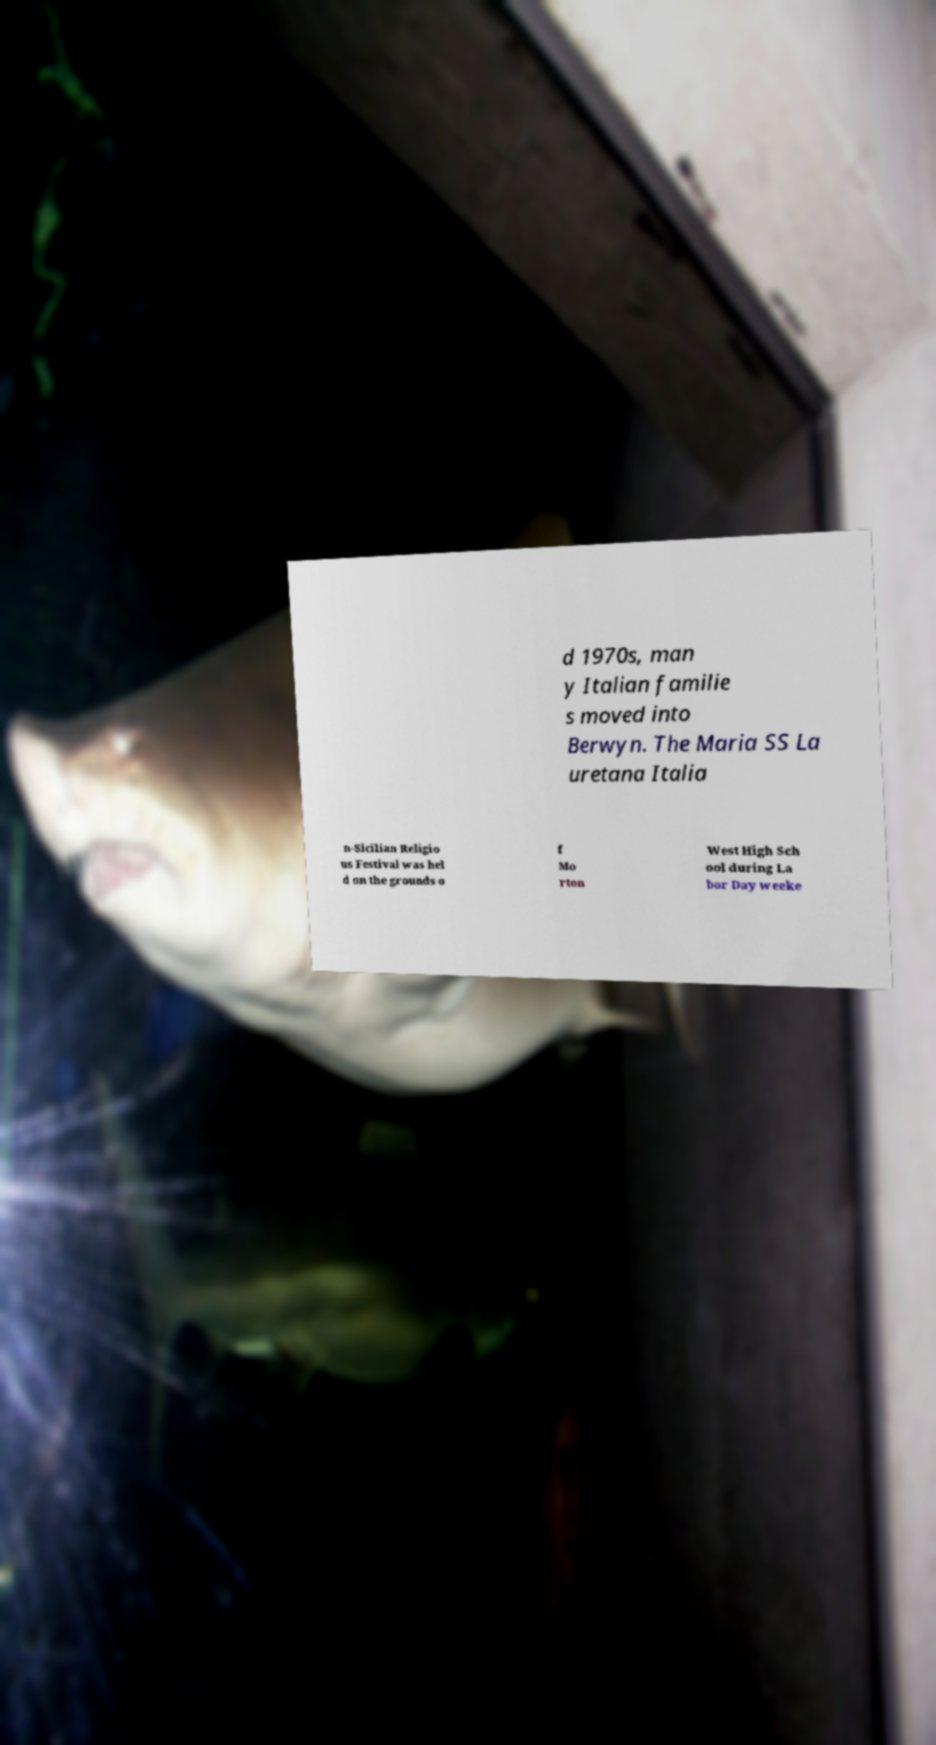Can you read and provide the text displayed in the image?This photo seems to have some interesting text. Can you extract and type it out for me? d 1970s, man y Italian familie s moved into Berwyn. The Maria SS La uretana Italia n-Sicilian Religio us Festival was hel d on the grounds o f Mo rton West High Sch ool during La bor Day weeke 